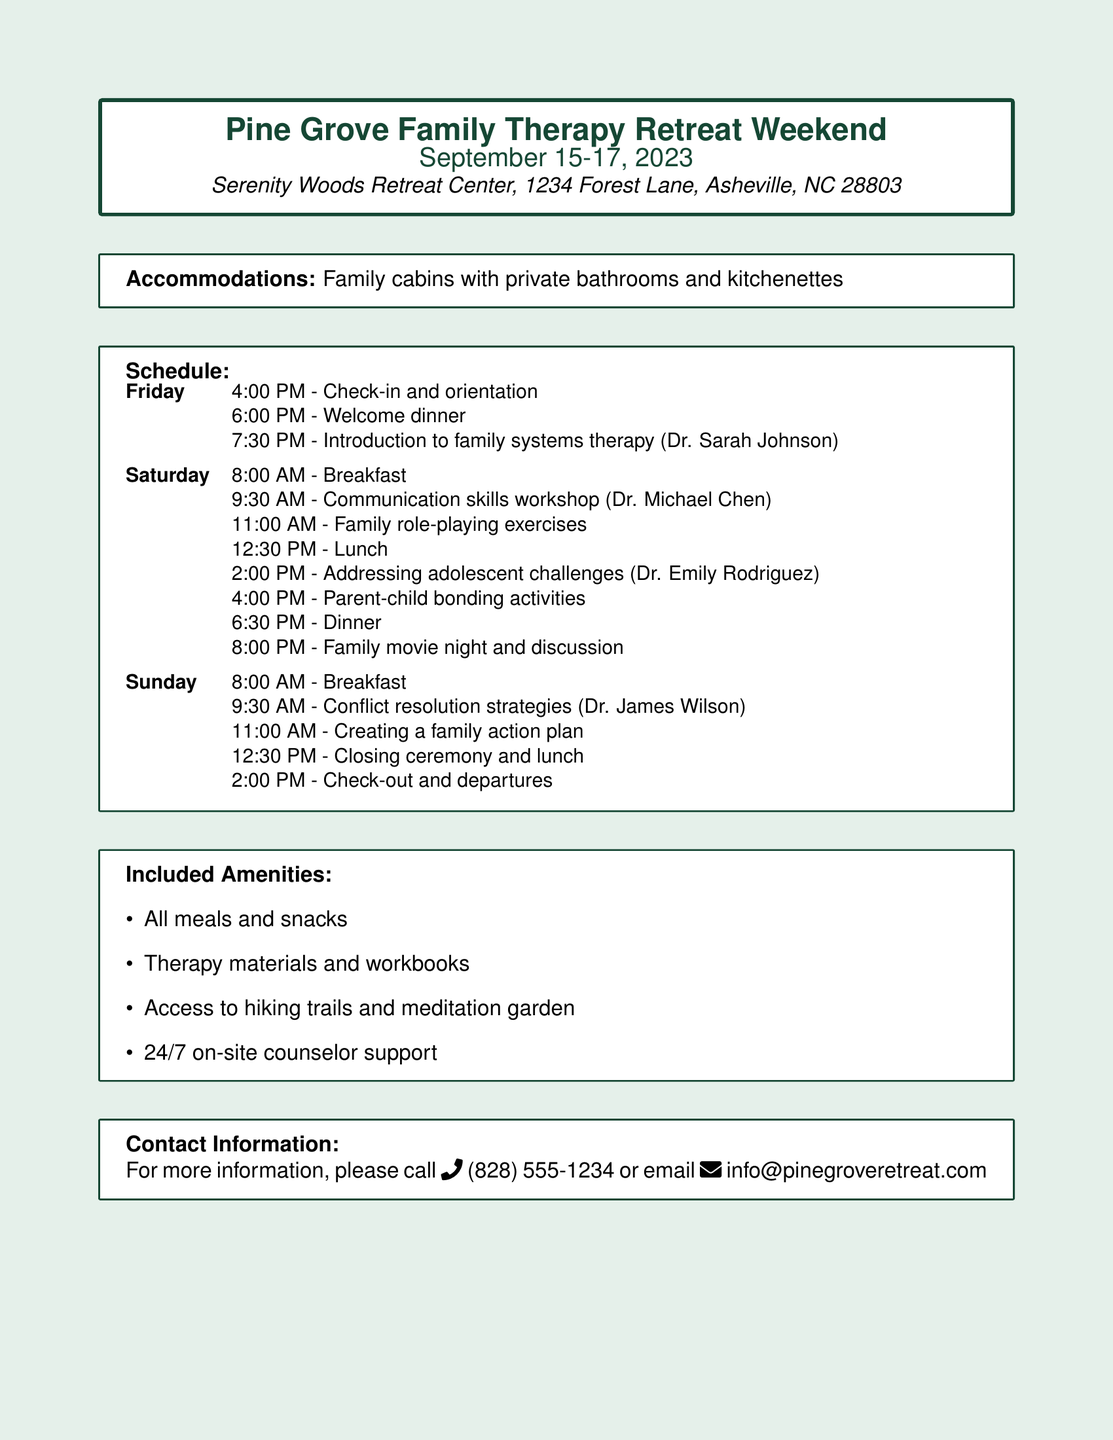What are the dates for the retreat? The retreat will take place from September 15 to September 17, 2023.
Answer: September 15-17, 2023 What time is the check-in on Friday? The check-in time on Friday is scheduled for 4:00 PM.
Answer: 4:00 PM Who is leading the communication skills workshop? The communication skills workshop will be led by Dr. Michael Chen.
Answer: Dr. Michael Chen What type of accommodation is provided? The accommodations consist of family cabins with private bathrooms and kitchenettes.
Answer: Family cabins with private bathrooms and kitchenettes What meal follows the conflict resolution strategies session? The meal after the conflict resolution strategies session is lunch.
Answer: Lunch How many parent-child bonding activities are scheduled? There is one scheduled parent-child bonding activity on Saturday at 4:00 PM.
Answer: One What included amenity allows for outdoor activity? Access to hiking trails is one of the included amenities that allows for outdoor activity.
Answer: Access to hiking trails What is the contact phone number for more information? The contact phone number provided for more information is (828) 555-1234.
Answer: (828) 555-1234 